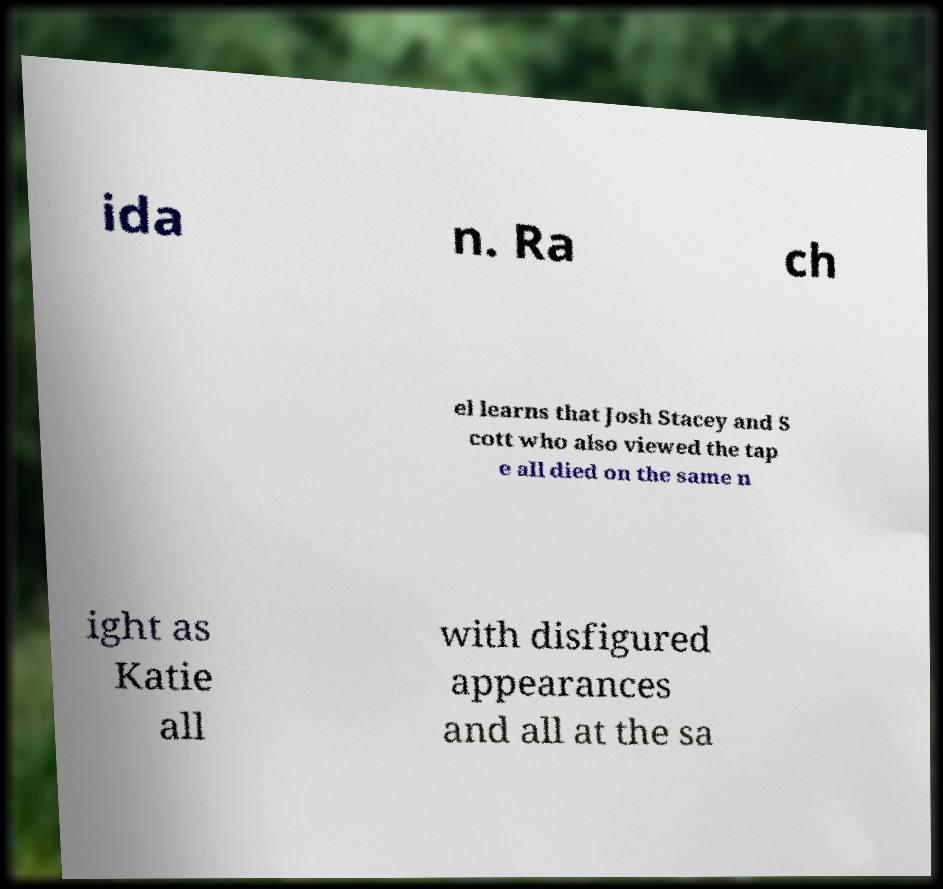Could you extract and type out the text from this image? ida n. Ra ch el learns that Josh Stacey and S cott who also viewed the tap e all died on the same n ight as Katie all with disfigured appearances and all at the sa 